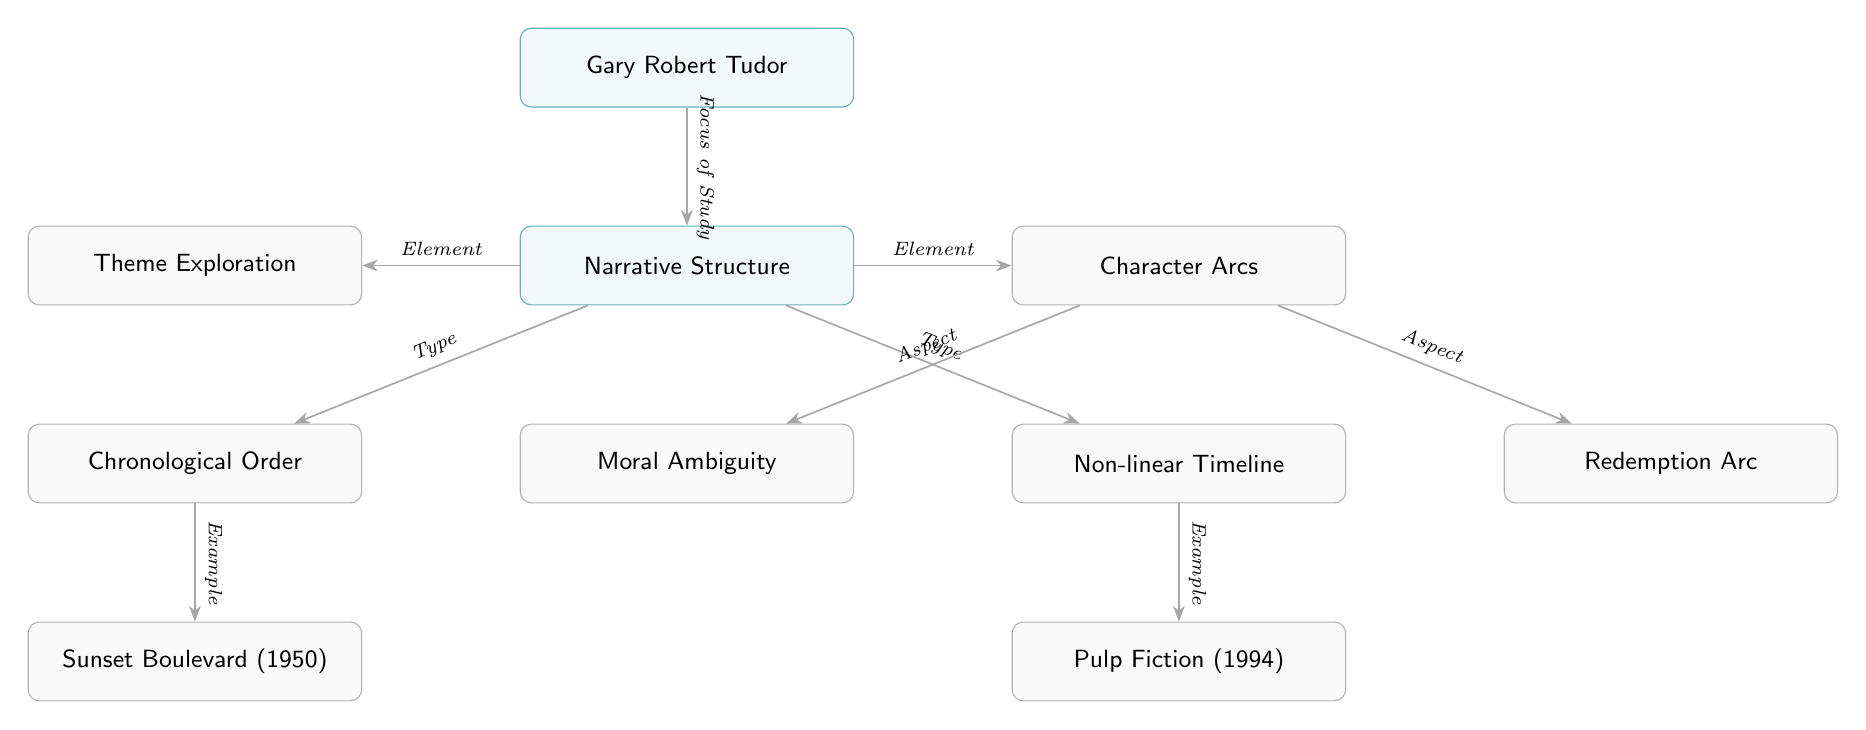What is the focus of study in the diagram? The topmost node, labeled "Gary Robert Tudor," connects to the "Narrative Structure" node with an edge labeled "Focus of Study."
Answer: Narrative Structure How many examples are provided for chronological order? The node "Chronological Order" has one edge leading to the example "Sunset Boulevard (1950)," indicating there is one example associated with that category.
Answer: 1 What type of narrative structure is represented by "Pulp Fiction"? The node "Pulp Fiction (1994)" is connected to the "Non-linear Timeline" node through an edge labeled "Example," indicating that this screenplay represents a non-linear narrative structure.
Answer: Non-linear Timeline What are the aspects linked to character arcs? The "Character Arcs" node has two edges leading to the aspects "Moral Ambiguity" and "Redemption Arc," which show the different aspects categorized under character arcs in Tudor's works.
Answer: Moral Ambiguity, Redemption Arc Which screenplay is an example of chronological order? The diagram shows an edge from "Chronological Order" to "Sunset Boulevard (1950)," making it clear that this screenplay is highlighted as an example of chronological order.
Answer: Sunset Boulevard (1950) How many main nodes are there in the diagram? The main nodes include "Gary Robert Tudor," "Narrative Structure," "Chronological Order," "Non-linear Timeline," "Character Arcs," and "Theme Exploration." Counting these shows there are six main nodes in total.
Answer: 6 What do the edges in the diagram typically represent? The edges in the diagram represent relationships between different narrative elements, either showing examples, types, or aspects connecting nodes.
Answer: Relationships Which theme exploration is linked to character arcs? The node "Theme Exploration" connects to the "Character Arcs" node, suggesting that theme exploration is a critical component related to character arcs, and it can encompass both "Moral Ambiguity" and "Redemption Arc."
Answer: Character Arcs What does the diagram indicate about the narrative structures studied? The diagram indicates the differences between chronological and non-linear narrative structures along with the exploration of character arcs and themes as key elements of narrative analysis in Tudor's works.
Answer: Narrative Structures 